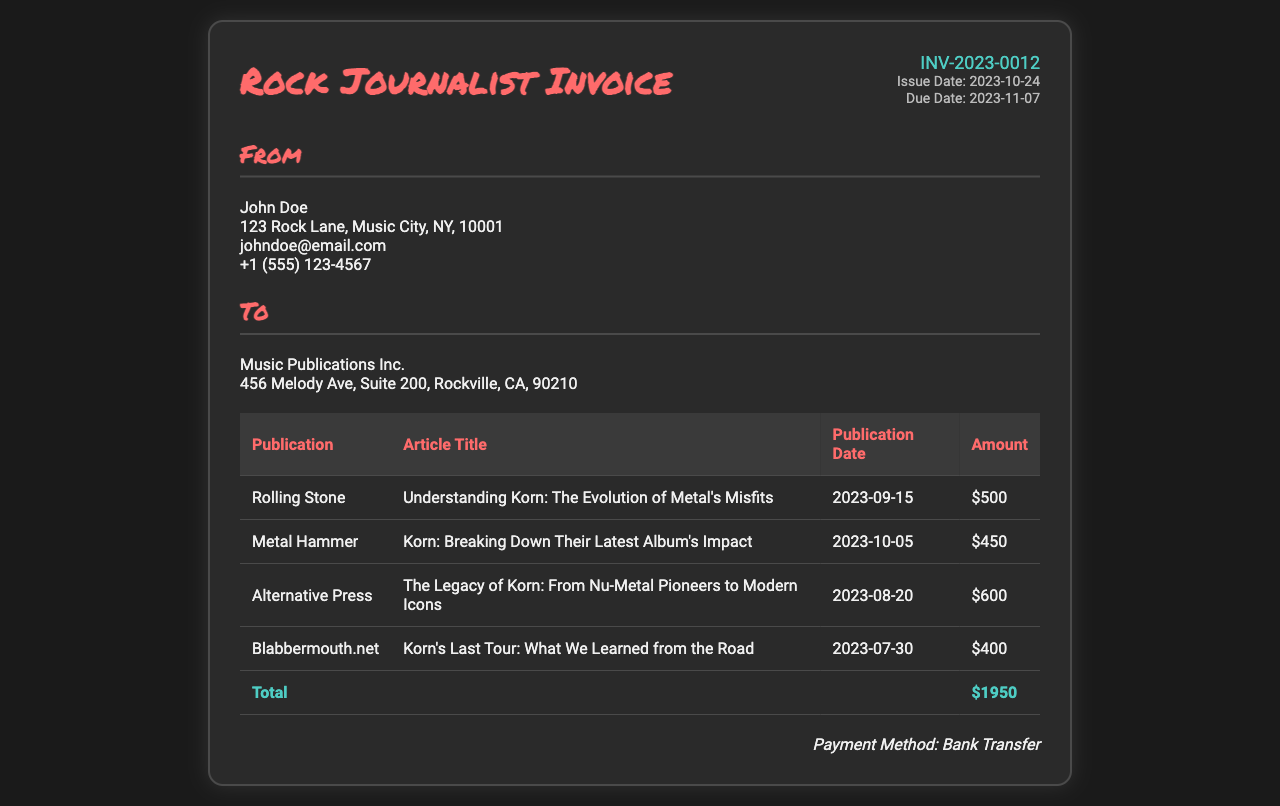what is the invoice number? The invoice number is listed prominently in the header section of the document as INV-2023-0012.
Answer: INV-2023-0012 who is the client? The client is detailed in the "To" section of the document and states Music Publications Inc.
Answer: Music Publications Inc what is the total amount due? The total amount due is calculated and presented in the last row of the table as $1950.
Answer: $1950 when was the article "Understanding Korn: The Evolution of Metal's Misfits" published? The publication date for this article is provided in the table, which states it was published on 2023-09-15.
Answer: 2023-09-15 how many articles related to Korn are listed in the invoice? To find this, we count the number of articles in the table, which lists four separate articles.
Answer: 4 what is the payment method stated in the document? The payment method is mentioned at the bottom of the invoice as Bank Transfer.
Answer: Bank Transfer which publication featured the article with the title "Korn: Breaking Down Their Latest Album's Impact"? The article titled "Korn: Breaking Down Their Latest Album's Impact" is published in Metal Hammer according to the table.
Answer: Metal Hammer what is the publication date of the last article listed? The last article listed in the table is "Korn's Last Tour: What We Learned from the Road," published on 2023-07-30.
Answer: 2023-07-30 